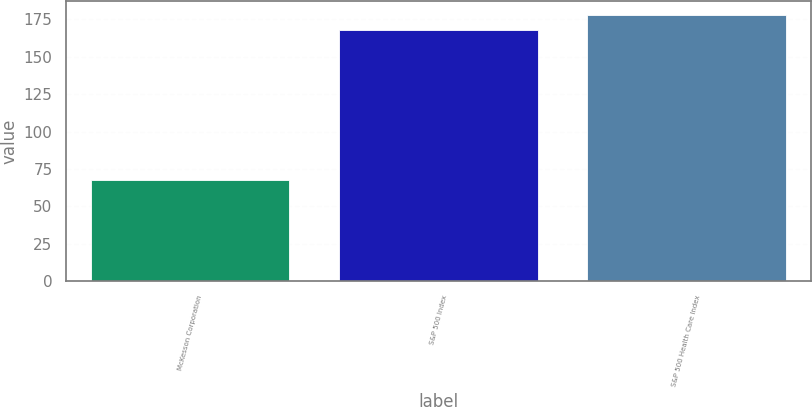Convert chart. <chart><loc_0><loc_0><loc_500><loc_500><bar_chart><fcel>McKesson Corporation<fcel>S&P 500 Index<fcel>S&P 500 Health Care Index<nl><fcel>67.45<fcel>167.81<fcel>178.13<nl></chart> 